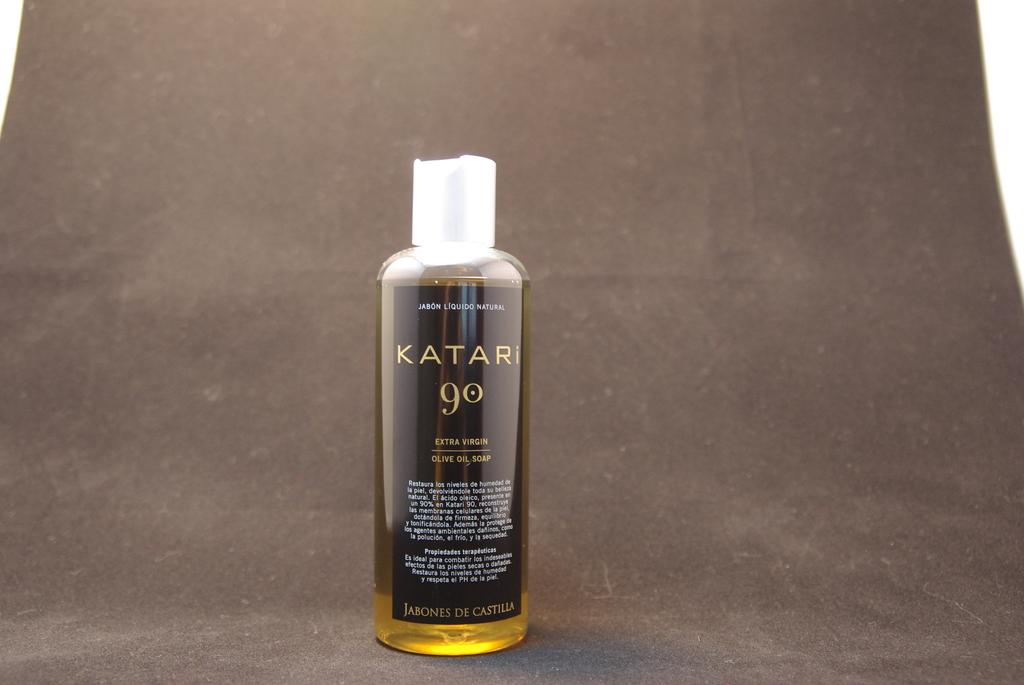What is this liquid called?
Offer a very short reply. Katari 90. What is the number on bottle?
Offer a very short reply. 90. 